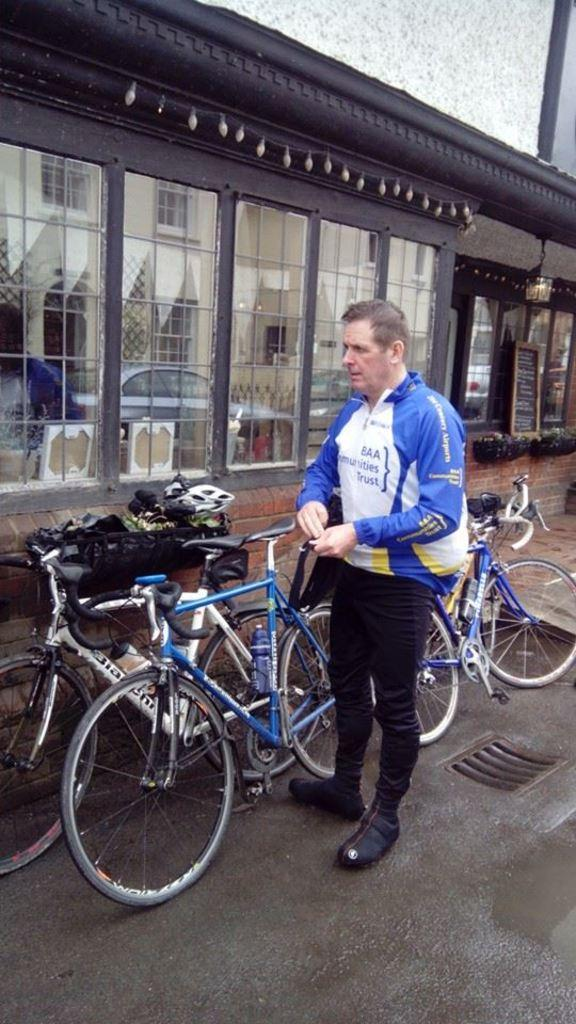What is the man in the image doing? The man is standing on the road. What can be seen near the man? There are bicycles beside the man. What is visible in the background of the image? There is a shop in the background of the image. Is there a girl standing next to the man, and is she holding a gate? There is no girl or gate present in the image. 